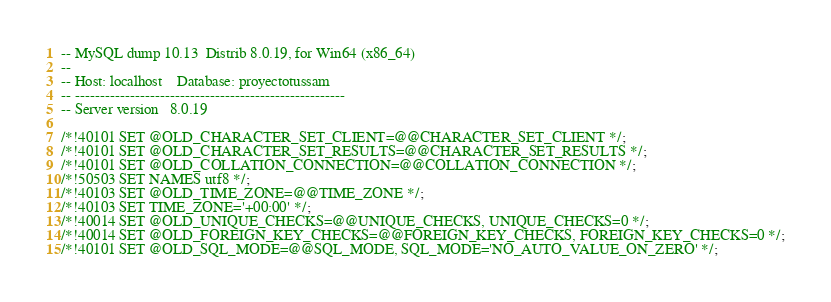<code> <loc_0><loc_0><loc_500><loc_500><_SQL_>-- MySQL dump 10.13  Distrib 8.0.19, for Win64 (x86_64)
--
-- Host: localhost    Database: proyectotussam
-- ------------------------------------------------------
-- Server version	8.0.19

/*!40101 SET @OLD_CHARACTER_SET_CLIENT=@@CHARACTER_SET_CLIENT */;
/*!40101 SET @OLD_CHARACTER_SET_RESULTS=@@CHARACTER_SET_RESULTS */;
/*!40101 SET @OLD_COLLATION_CONNECTION=@@COLLATION_CONNECTION */;
/*!50503 SET NAMES utf8 */;
/*!40103 SET @OLD_TIME_ZONE=@@TIME_ZONE */;
/*!40103 SET TIME_ZONE='+00:00' */;
/*!40014 SET @OLD_UNIQUE_CHECKS=@@UNIQUE_CHECKS, UNIQUE_CHECKS=0 */;
/*!40014 SET @OLD_FOREIGN_KEY_CHECKS=@@FOREIGN_KEY_CHECKS, FOREIGN_KEY_CHECKS=0 */;
/*!40101 SET @OLD_SQL_MODE=@@SQL_MODE, SQL_MODE='NO_AUTO_VALUE_ON_ZERO' */;</code> 